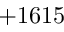Convert formula to latex. <formula><loc_0><loc_0><loc_500><loc_500>+ 1 6 1 5</formula> 